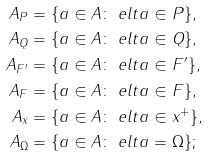<formula> <loc_0><loc_0><loc_500><loc_500>A _ { P } & = \{ a \in A \colon \ e l t { a } \in P \} , \\ A _ { Q } & = \{ a \in A \colon \ e l t { a } \in Q \} , \\ A _ { F ^ { \prime } } & = \{ a \in A \colon \ e l t { a } \in F ^ { \prime } \} , \\ A _ { F } & = \{ a \in A \colon \ e l t { a } \in F \} , \\ A _ { x } & = \{ a \in A \colon \ e l t { a } \in x ^ { + } \} , \\ A _ { \Omega } & = \{ a \in A \colon \ e l t { a } = \Omega \} ;</formula> 